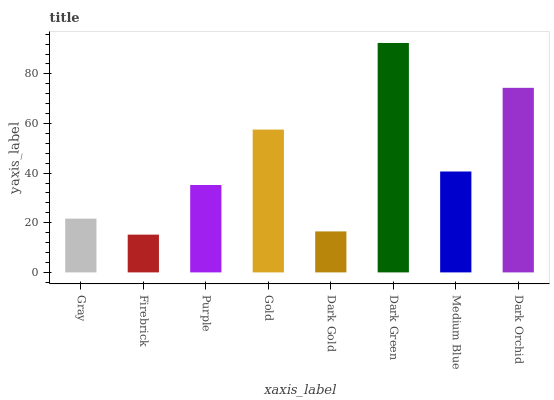Is Purple the minimum?
Answer yes or no. No. Is Purple the maximum?
Answer yes or no. No. Is Purple greater than Firebrick?
Answer yes or no. Yes. Is Firebrick less than Purple?
Answer yes or no. Yes. Is Firebrick greater than Purple?
Answer yes or no. No. Is Purple less than Firebrick?
Answer yes or no. No. Is Medium Blue the high median?
Answer yes or no. Yes. Is Purple the low median?
Answer yes or no. Yes. Is Purple the high median?
Answer yes or no. No. Is Dark Orchid the low median?
Answer yes or no. No. 